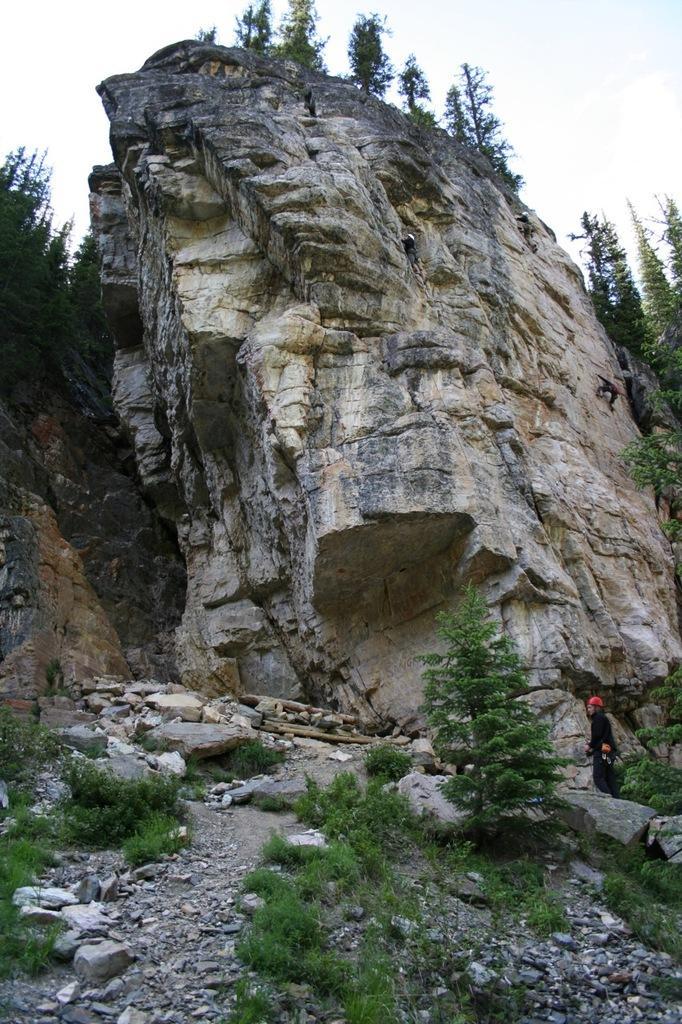Describe this image in one or two sentences. There is a person standing and we can see plants and trees. We can see rocks and these people are climbing on this rock. 